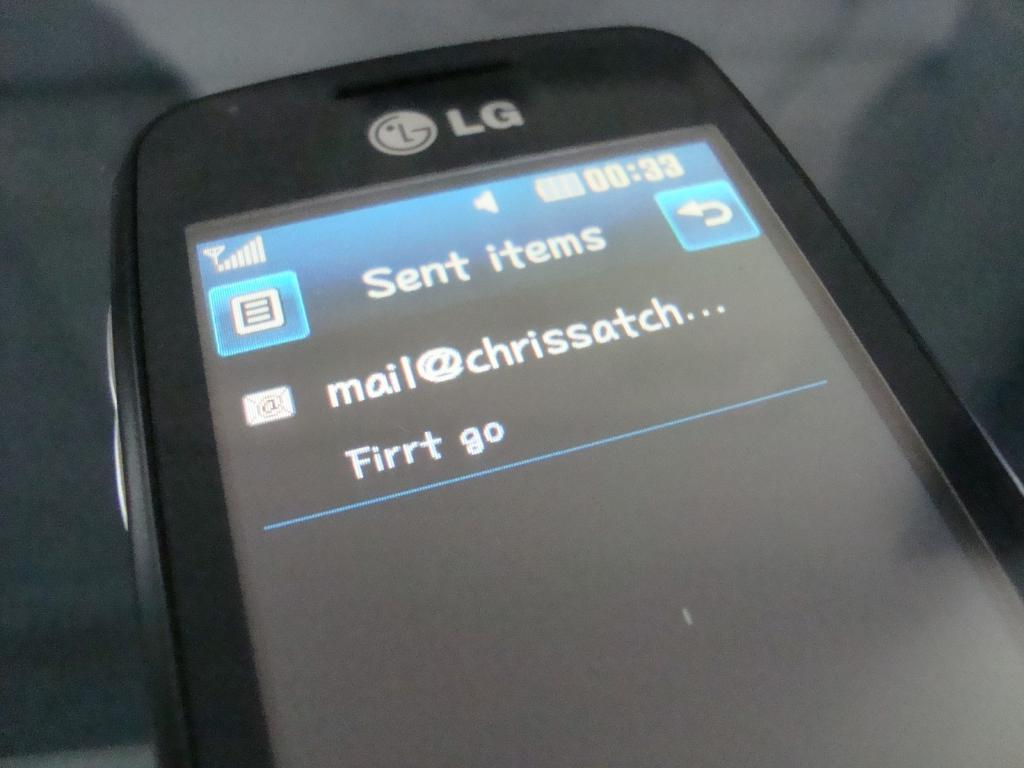Provide a one-sentence caption for the provided image. Someone with an LG phone sent an email to Chris. 